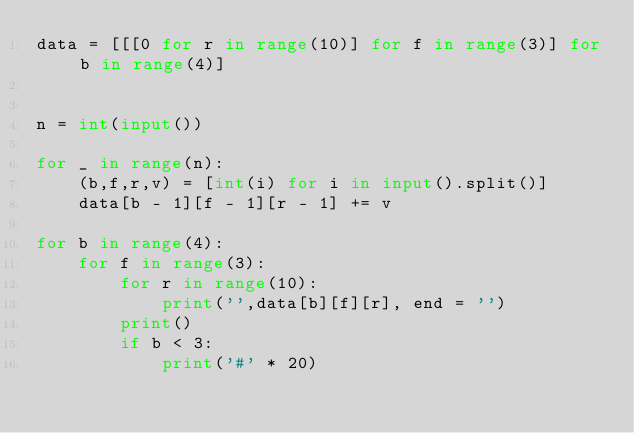<code> <loc_0><loc_0><loc_500><loc_500><_Python_>data = [[[0 for r in range(10)] for f in range(3)] for b in range(4)]


n = int(input())

for _ in range(n):
    (b,f,r,v) = [int(i) for i in input().split()]
    data[b - 1][f - 1][r - 1] += v

for b in range(4):
    for f in range(3):
        for r in range(10):
            print('',data[b][f][r], end = '')
        print()
        if b < 3:
            print('#' * 20)</code> 